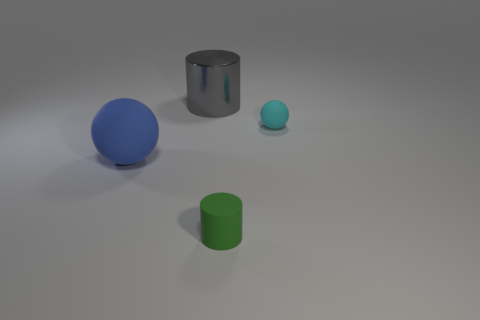Add 3 big gray matte balls. How many objects exist? 7 Subtract all matte objects. Subtract all small green cylinders. How many objects are left? 0 Add 1 large cylinders. How many large cylinders are left? 2 Add 4 gray metallic cylinders. How many gray metallic cylinders exist? 5 Subtract 0 purple balls. How many objects are left? 4 